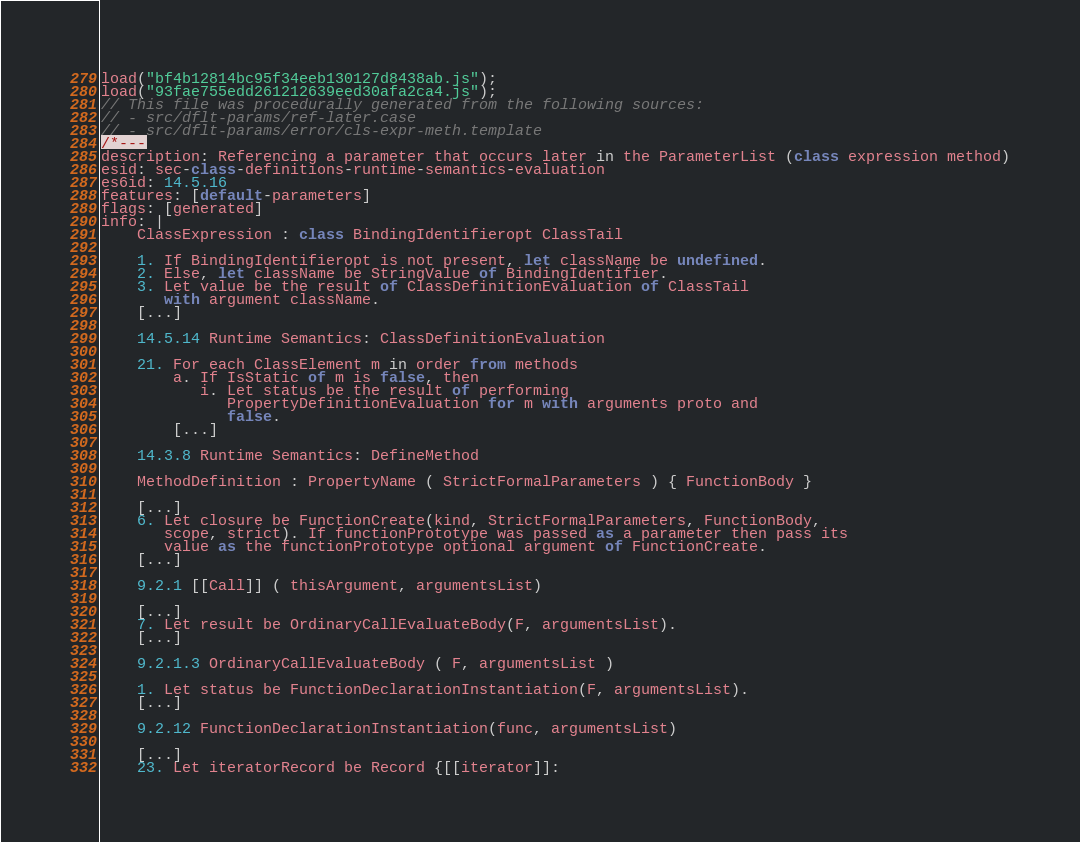Convert code to text. <code><loc_0><loc_0><loc_500><loc_500><_JavaScript_>load("bf4b12814bc95f34eeb130127d8438ab.js");
load("93fae755edd261212639eed30afa2ca4.js");
// This file was procedurally generated from the following sources:
// - src/dflt-params/ref-later.case
// - src/dflt-params/error/cls-expr-meth.template
/*---
description: Referencing a parameter that occurs later in the ParameterList (class expression method)
esid: sec-class-definitions-runtime-semantics-evaluation
es6id: 14.5.16
features: [default-parameters]
flags: [generated]
info: |
    ClassExpression : class BindingIdentifieropt ClassTail

    1. If BindingIdentifieropt is not present, let className be undefined.
    2. Else, let className be StringValue of BindingIdentifier.
    3. Let value be the result of ClassDefinitionEvaluation of ClassTail
       with argument className.
    [...]

    14.5.14 Runtime Semantics: ClassDefinitionEvaluation

    21. For each ClassElement m in order from methods
        a. If IsStatic of m is false, then
           i. Let status be the result of performing
              PropertyDefinitionEvaluation for m with arguments proto and
              false.
        [...]

    14.3.8 Runtime Semantics: DefineMethod

    MethodDefinition : PropertyName ( StrictFormalParameters ) { FunctionBody }

    [...]
    6. Let closure be FunctionCreate(kind, StrictFormalParameters, FunctionBody,
       scope, strict). If functionPrototype was passed as a parameter then pass its
       value as the functionPrototype optional argument of FunctionCreate.
    [...]

    9.2.1 [[Call]] ( thisArgument, argumentsList)

    [...]
    7. Let result be OrdinaryCallEvaluateBody(F, argumentsList).
    [...]

    9.2.1.3 OrdinaryCallEvaluateBody ( F, argumentsList )

    1. Let status be FunctionDeclarationInstantiation(F, argumentsList).
    [...]

    9.2.12 FunctionDeclarationInstantiation(func, argumentsList)

    [...]
    23. Let iteratorRecord be Record {[[iterator]]:</code> 